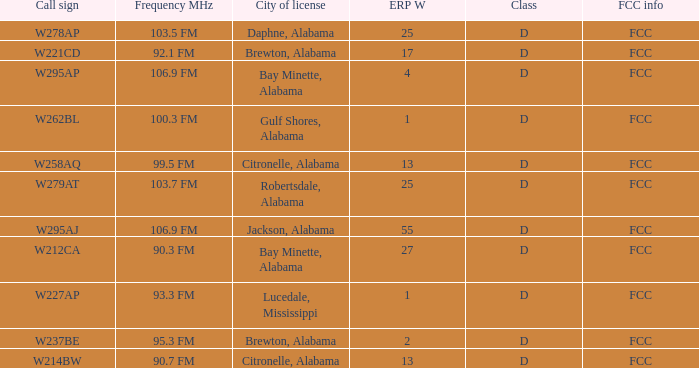Identify the fcc information for the call sign w279at. FCC. 